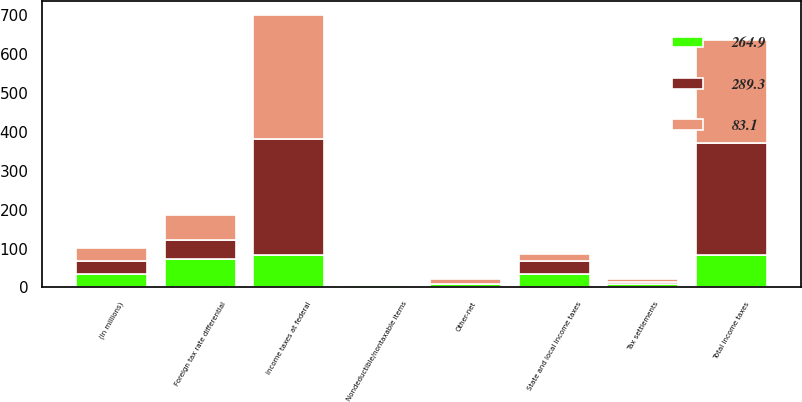<chart> <loc_0><loc_0><loc_500><loc_500><stacked_bar_chart><ecel><fcel>(In millions)<fcel>Income taxes at federal<fcel>State and local income taxes<fcel>Foreign tax rate differential<fcel>Nondeductible/nontaxable items<fcel>Tax settlements<fcel>Other-net<fcel>Total income taxes<nl><fcel>264.9<fcel>34<fcel>83.9<fcel>34.5<fcel>72<fcel>5.9<fcel>8<fcel>8.4<fcel>83.1<nl><fcel>83.1<fcel>34<fcel>319<fcel>17.6<fcel>63.4<fcel>3<fcel>6.6<fcel>11.9<fcel>264.9<nl><fcel>289.3<fcel>34<fcel>298<fcel>34<fcel>50<fcel>0.1<fcel>6.6<fcel>0.6<fcel>289.3<nl></chart> 